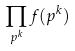Convert formula to latex. <formula><loc_0><loc_0><loc_500><loc_500>\prod _ { p ^ { k } } f ( p ^ { k } )</formula> 